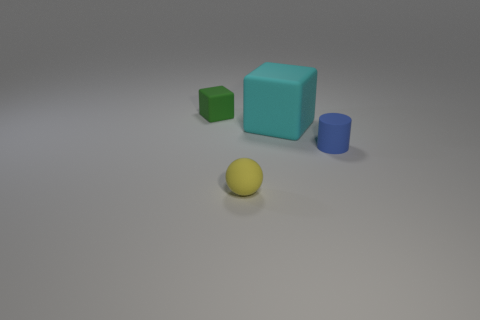Add 1 blue metallic cylinders. How many objects exist? 5 Subtract all balls. How many objects are left? 3 Add 4 tiny yellow matte spheres. How many tiny yellow matte spheres are left? 5 Add 1 tiny green rubber objects. How many tiny green rubber objects exist? 2 Subtract 0 green cylinders. How many objects are left? 4 Subtract all big cyan rubber things. Subtract all green objects. How many objects are left? 2 